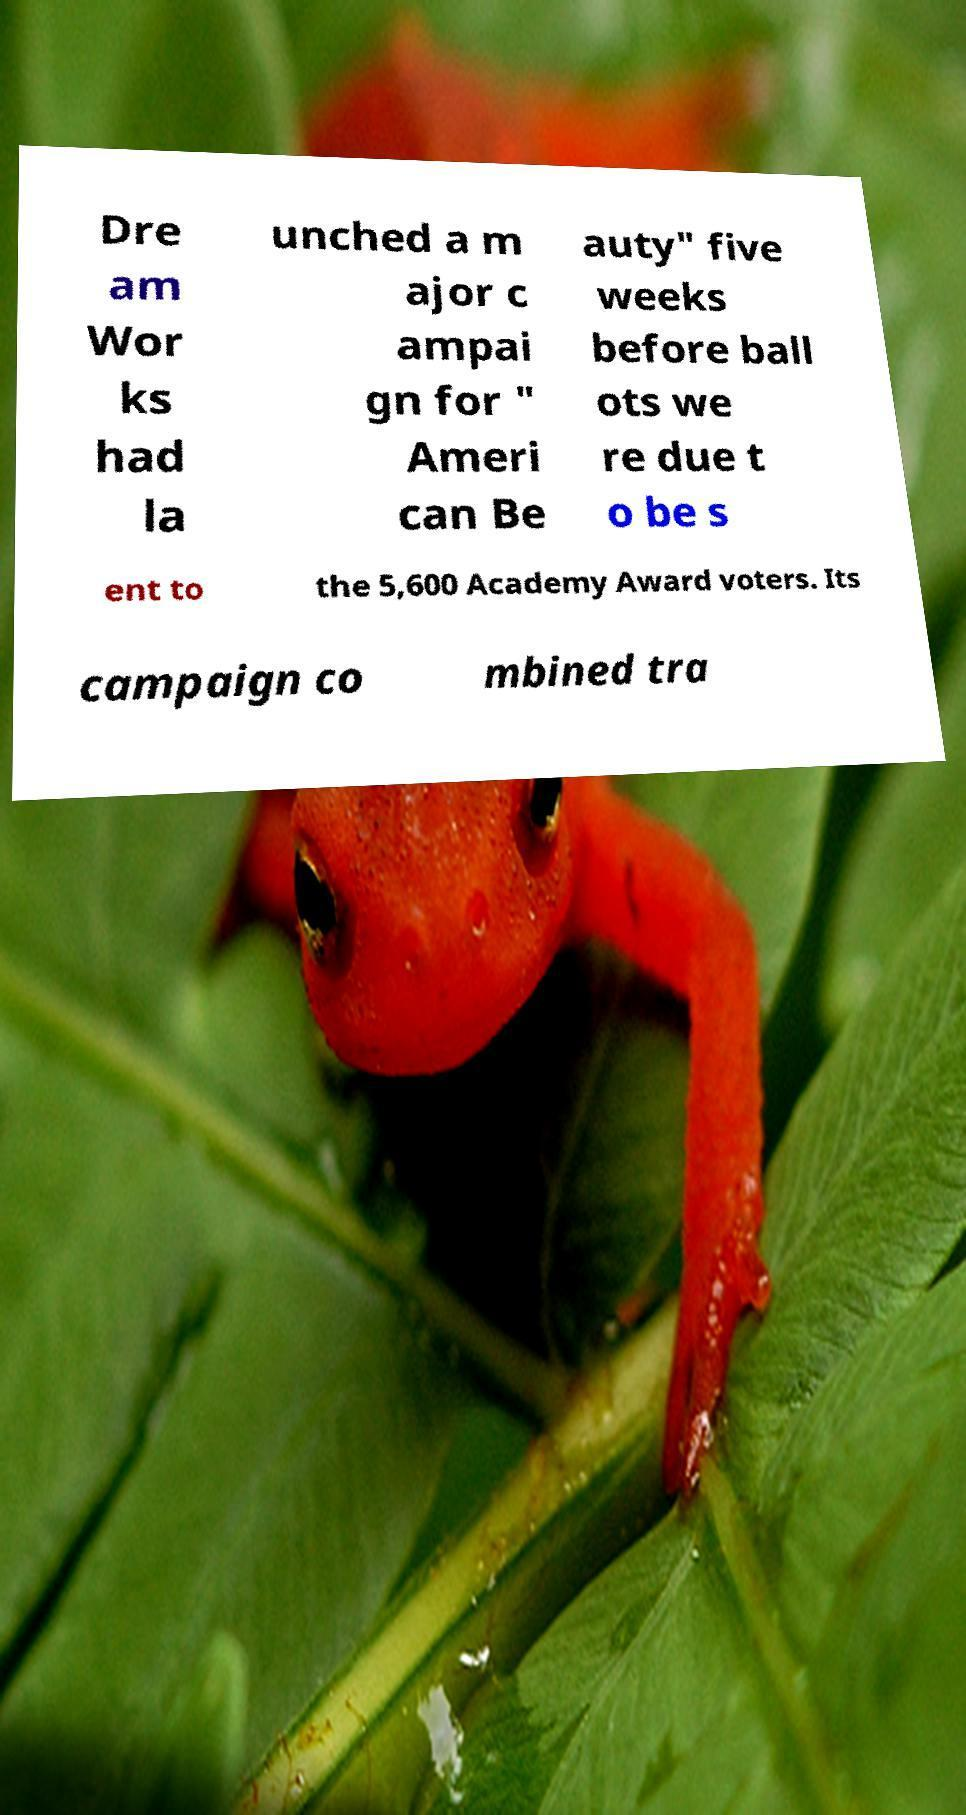Please read and relay the text visible in this image. What does it say? Dre am Wor ks had la unched a m ajor c ampai gn for " Ameri can Be auty" five weeks before ball ots we re due t o be s ent to the 5,600 Academy Award voters. Its campaign co mbined tra 